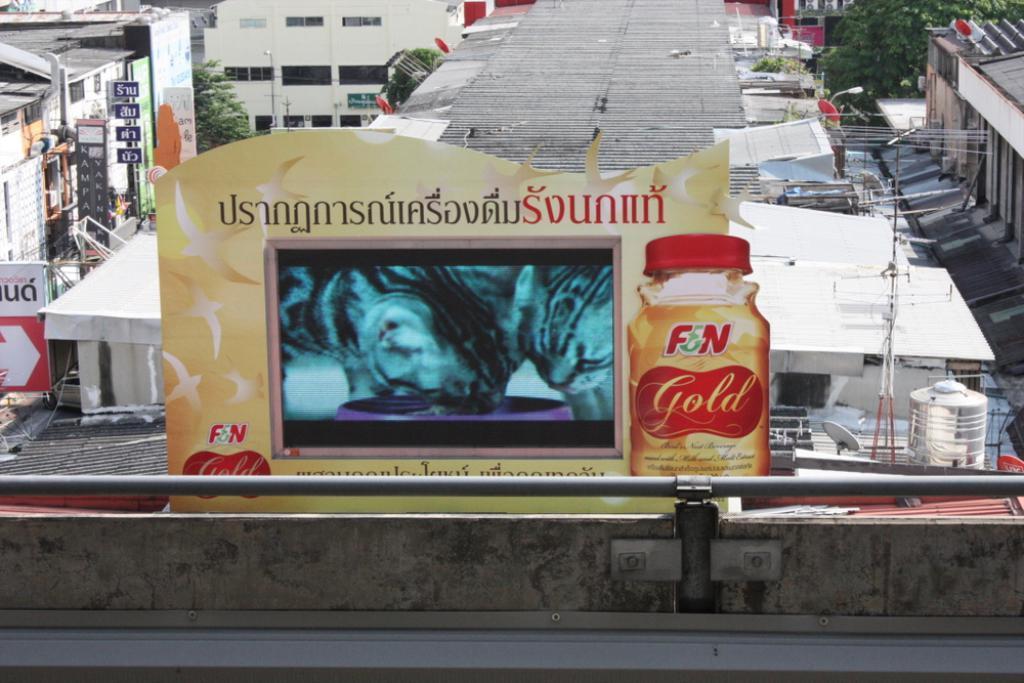Can you describe this image briefly? At the bottom of the image there is a small wall with rod. Behind the wall there is a poster with images and something written on it. In the background there are buildings with walls, roofs and windows. And also there are electrical pole with wires, dish antenna, tank and also there are trees. 